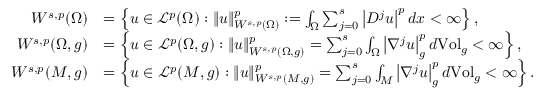Convert formula to latex. <formula><loc_0><loc_0><loc_500><loc_500>\begin{array} { r l } { W ^ { s , p } ( \Omega ) } & { = \left \{ u \in \mathcal { L } ^ { p } ( \Omega ) \colon \| u \| _ { W ^ { s , p } ( \Omega ) } ^ { p } \colon = \int _ { \Omega } \sum _ { j = 0 } ^ { s } \left | D ^ { j } u \right | ^ { p } d x < \infty \right \} , } \\ { W ^ { s , p } ( \Omega , g ) } & { = \left \{ u \in \mathcal { L } ^ { p } ( \Omega , g ) \colon \| u \| _ { W ^ { s , p } ( \Omega , g ) } ^ { p } = \sum _ { j = 0 } ^ { s } \int _ { \Omega } \left | \nabla ^ { j } u \right | _ { g } ^ { p } d V o l _ { g } < \infty \right \} , } \\ { W ^ { s , p } ( M , g ) } & { = \left \{ u \in \mathcal { L } ^ { p } ( M , g ) \colon \| u \| _ { W ^ { s , p } ( M , g ) } ^ { p } = \sum _ { j = 0 } ^ { s } \int _ { M } \left | \nabla ^ { j } u \right | _ { g } ^ { p } d V o l _ { g } < \infty \right \} . } \end{array}</formula> 